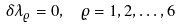Convert formula to latex. <formula><loc_0><loc_0><loc_500><loc_500>\delta \lambda _ { \varrho } = 0 , \text { \ } \varrho = 1 , 2 , \dots , 6</formula> 